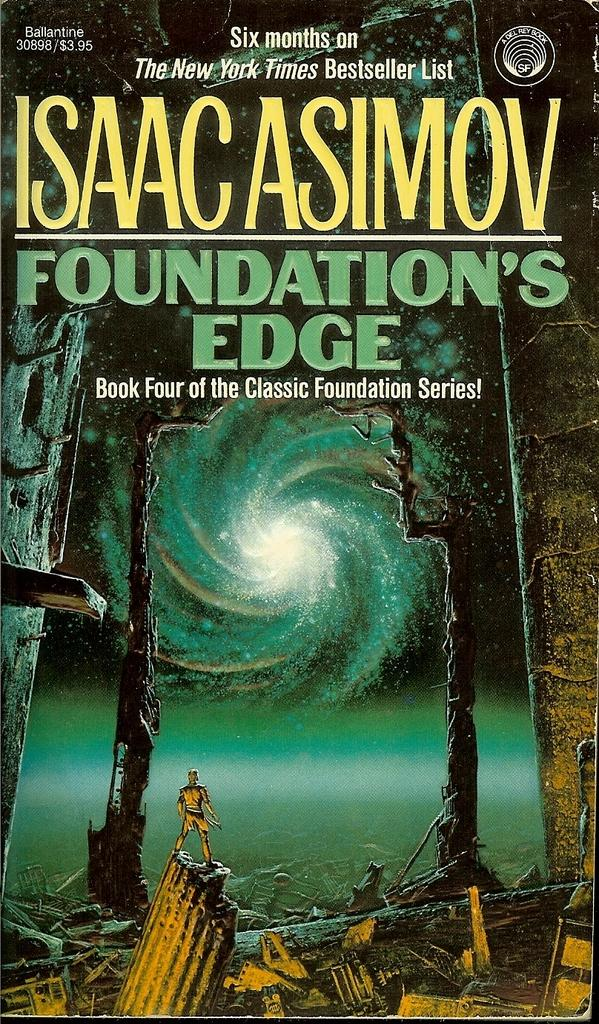Provide a one-sentence caption for the provided image. Science fiction book cover that appears to be under 4 dollars. 